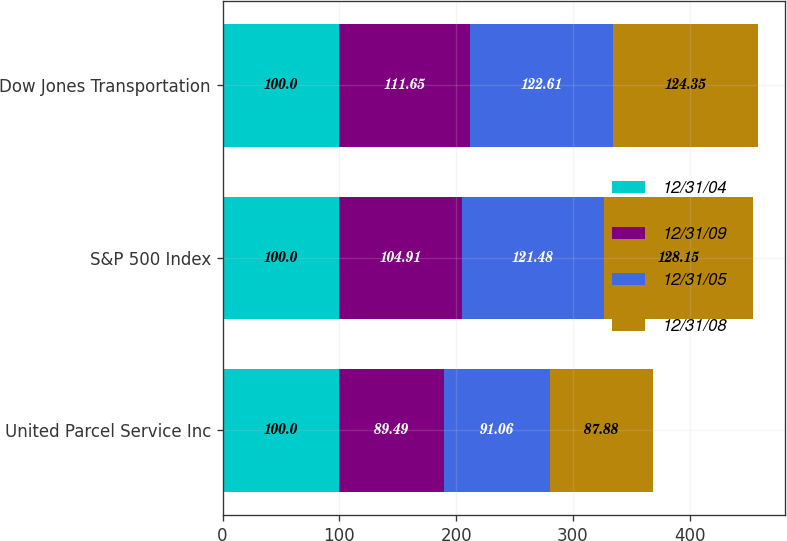Convert chart to OTSL. <chart><loc_0><loc_0><loc_500><loc_500><stacked_bar_chart><ecel><fcel>United Parcel Service Inc<fcel>S&P 500 Index<fcel>Dow Jones Transportation<nl><fcel>12/31/04<fcel>100<fcel>100<fcel>100<nl><fcel>12/31/09<fcel>89.49<fcel>104.91<fcel>111.65<nl><fcel>12/31/05<fcel>91.06<fcel>121.48<fcel>122.61<nl><fcel>12/31/08<fcel>87.88<fcel>128.15<fcel>124.35<nl></chart> 